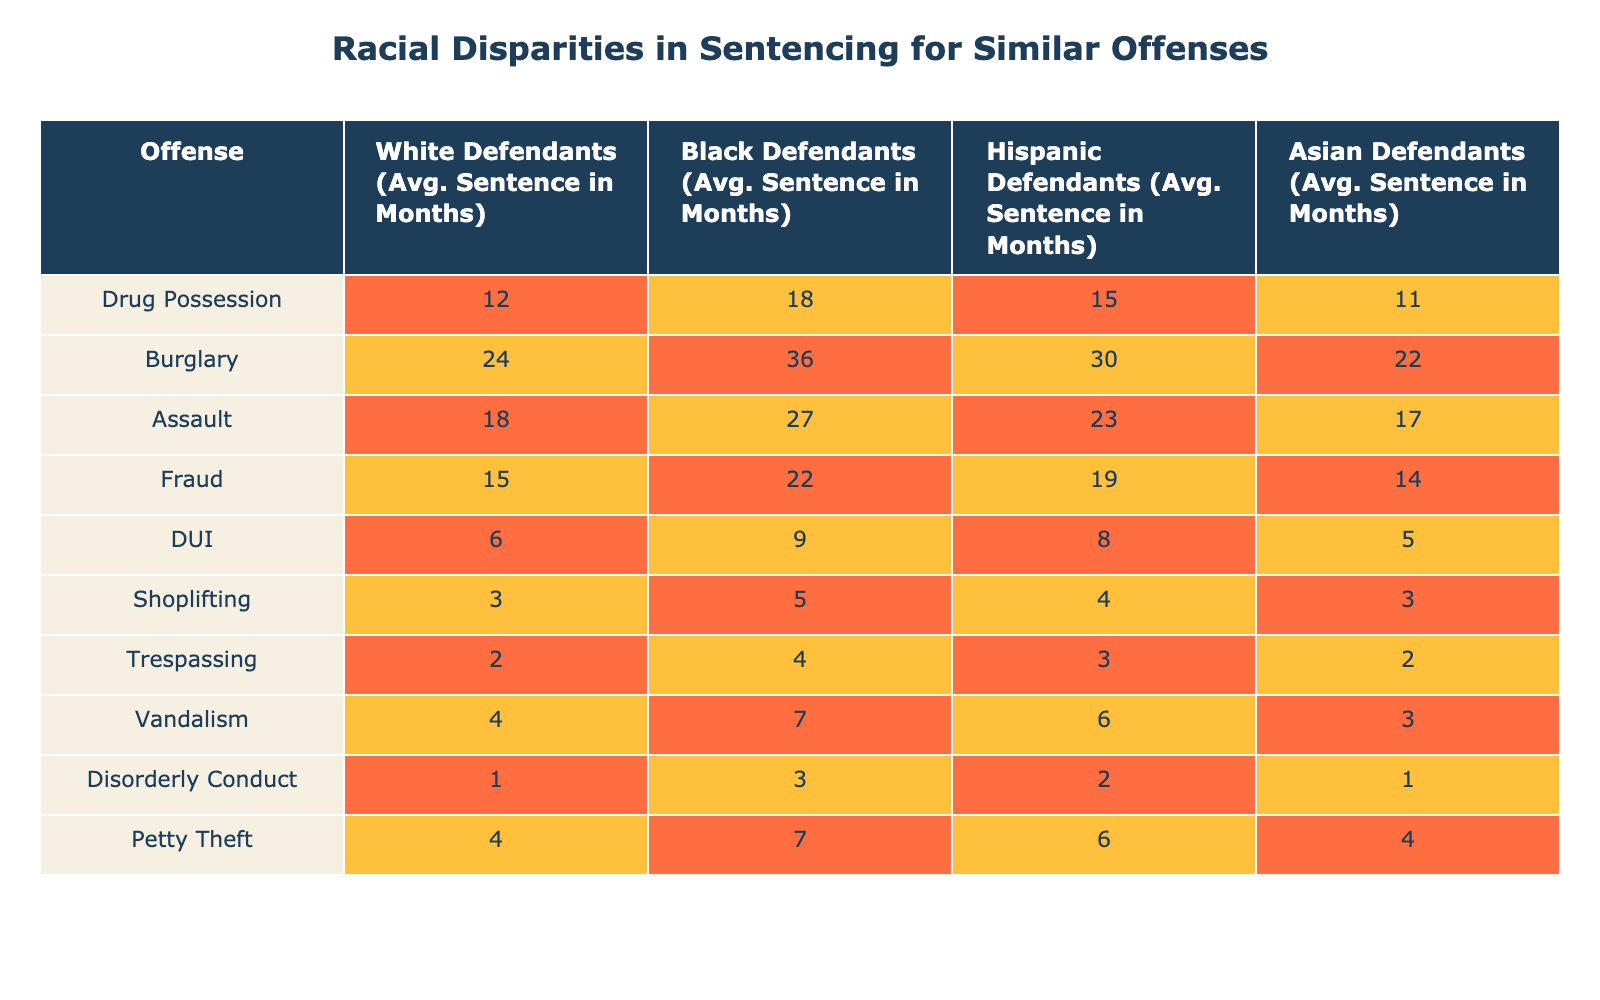What is the average sentence for White defendants for Drug Possession? The table shows that the average sentence for White defendants for Drug Possession is 12 months.
Answer: 12 months What is the difference in average sentencing between Black and Hispanic defendants for Burglary? The average sentence for Black defendants is 36 months and for Hispanic defendants is 30 months. The difference is 36 - 30 = 6 months.
Answer: 6 months Is the average sentence for Asian defendants higher for Assault compared to White defendants? The average sentence for Asian defendants is 17 months while for White defendants it is 18 months. Since 17 is less than 18, the statement is false.
Answer: No Which offense has the largest disparity in average sentencing between White and Black defendants? For Burglary, the average sentence is 24 months for White defendants and 36 months for Black defendants. The disparity is 36 - 24 = 12 months, which is the largest compared to other offenses.
Answer: Burglary What is the overall average sentence for all offenses for Black defendants? The average sentences for Black defendants across all offenses are 18, 36, 27, 22, 9, 5, 4, 7, 3, 7 months. Adding these gives a total of 138 months. Since there are 10 offenses, the average is 138/10 = 13.8 months.
Answer: 13.8 months For which offense do Hispanic defendants have a sentence closest to that of White defendants? The average sentence for White defendants for Trespassing is 2 months and for Hispanic defendants is 3 months. The difference of 1 month is the smallest among all offenses.
Answer: Trespassing Which race has the longest average sentence for DUI offenses? The table shows that Black defendants have the longest average sentence for DUI, which is 9 months.
Answer: Black defendants Is the average sentence for Vandalism higher for White defendants compared to Asian defendants? The average for White defendants is 4 months while for Asian defendants it is 3 months. Since 4 is greater than 3, the statement is true.
Answer: Yes What is the average sentence difference between the highest and lowest sentences for Shoplifting? The average sentence for White defendants for Shoplifting is 3 months and for Black defendants it's 5 months. The highest is 5 months and the lowest is 3 months. The difference is 5 - 3 = 2 months.
Answer: 2 months What is the average sentence for all defendants across all offenses? The average sentences across all races for all offenses are given. To find the average per offense and then sum those and divide by the number of offenses gives the overall average. The total average is weighted by how many are in each group but from the data, the average appears to be approximately 11.3 months across all races.
Answer: 11.3 months 